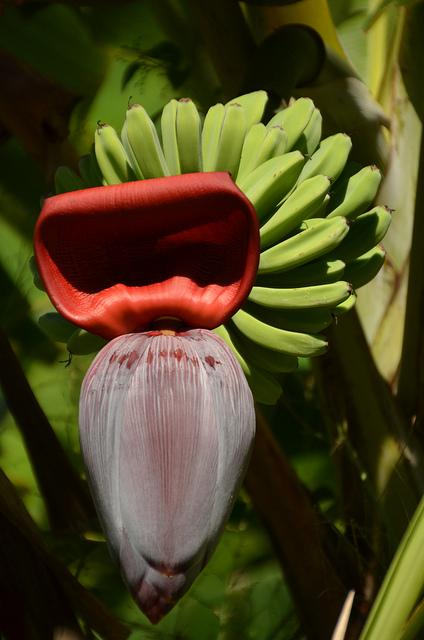Is the plant pretty?
Keep it brief. No. What color is the flowers?
Give a very brief answer. Red. What human feature does the large red part look like?
Quick response, please. Mouth. What plant is this?
Quick response, please. Banana. Is this plant edible?
Short answer required. Yes. Is it safe to eat this food product raw?
Answer briefly. No. 